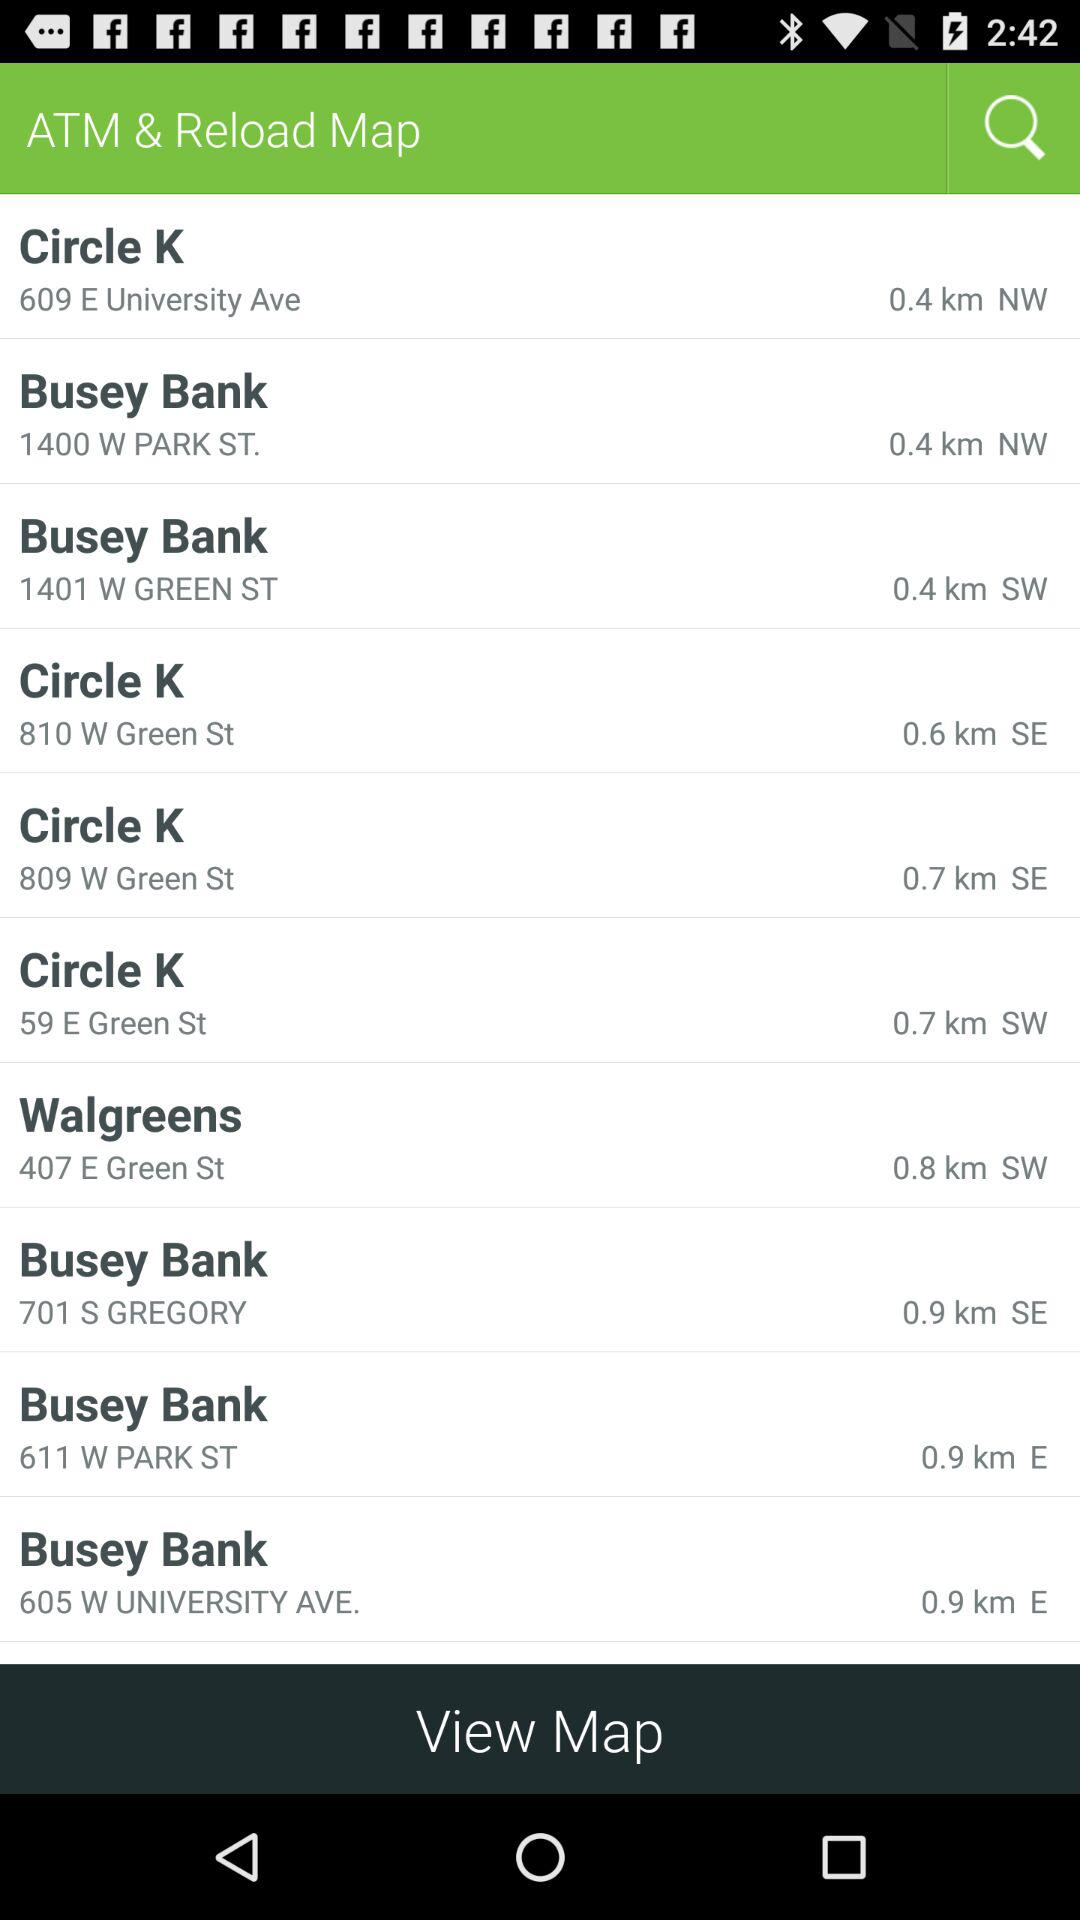Which ATM is at the nearest location?
When the provided information is insufficient, respond with <no answer>. <no answer> 